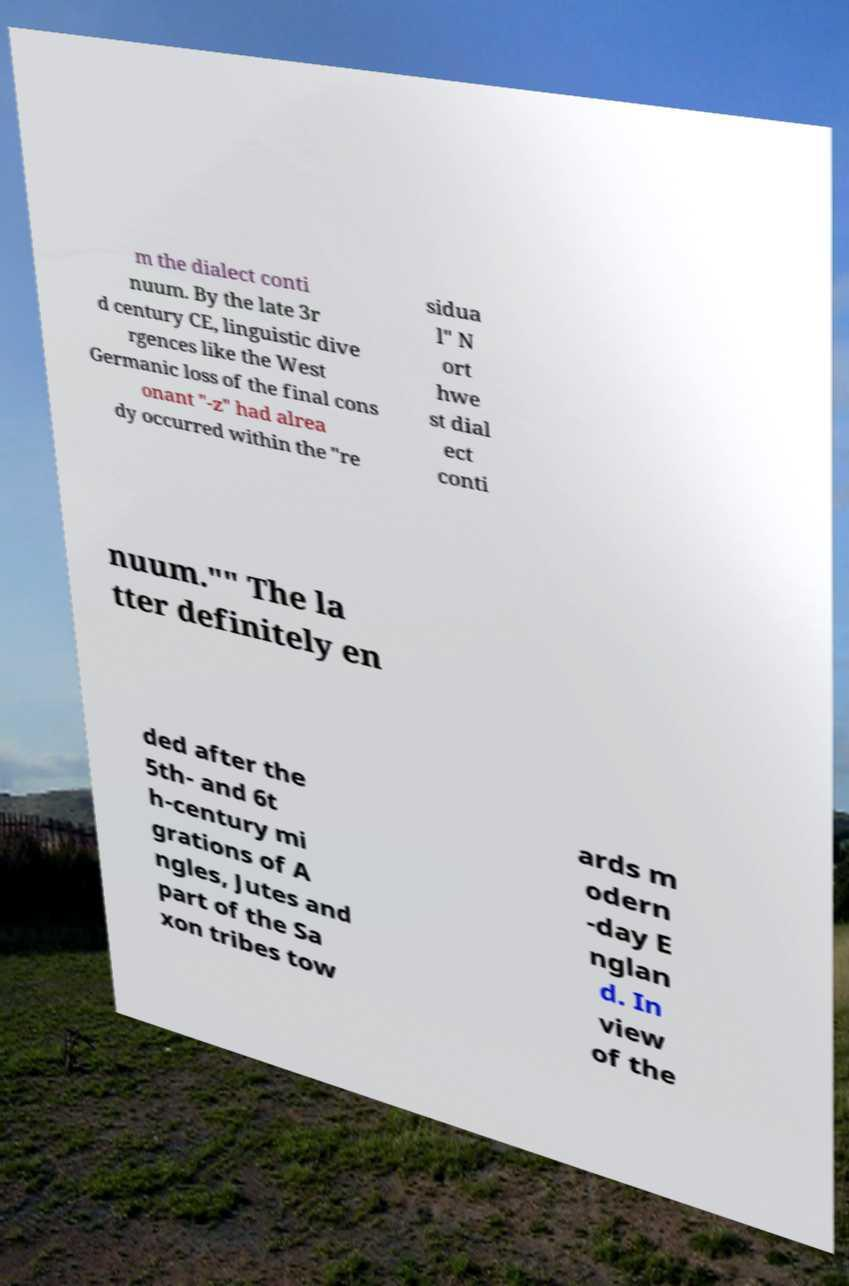I need the written content from this picture converted into text. Can you do that? m the dialect conti nuum. By the late 3r d century CE, linguistic dive rgences like the West Germanic loss of the final cons onant "-z" had alrea dy occurred within the "re sidua l" N ort hwe st dial ect conti nuum."" The la tter definitely en ded after the 5th- and 6t h-century mi grations of A ngles, Jutes and part of the Sa xon tribes tow ards m odern -day E nglan d. In view of the 